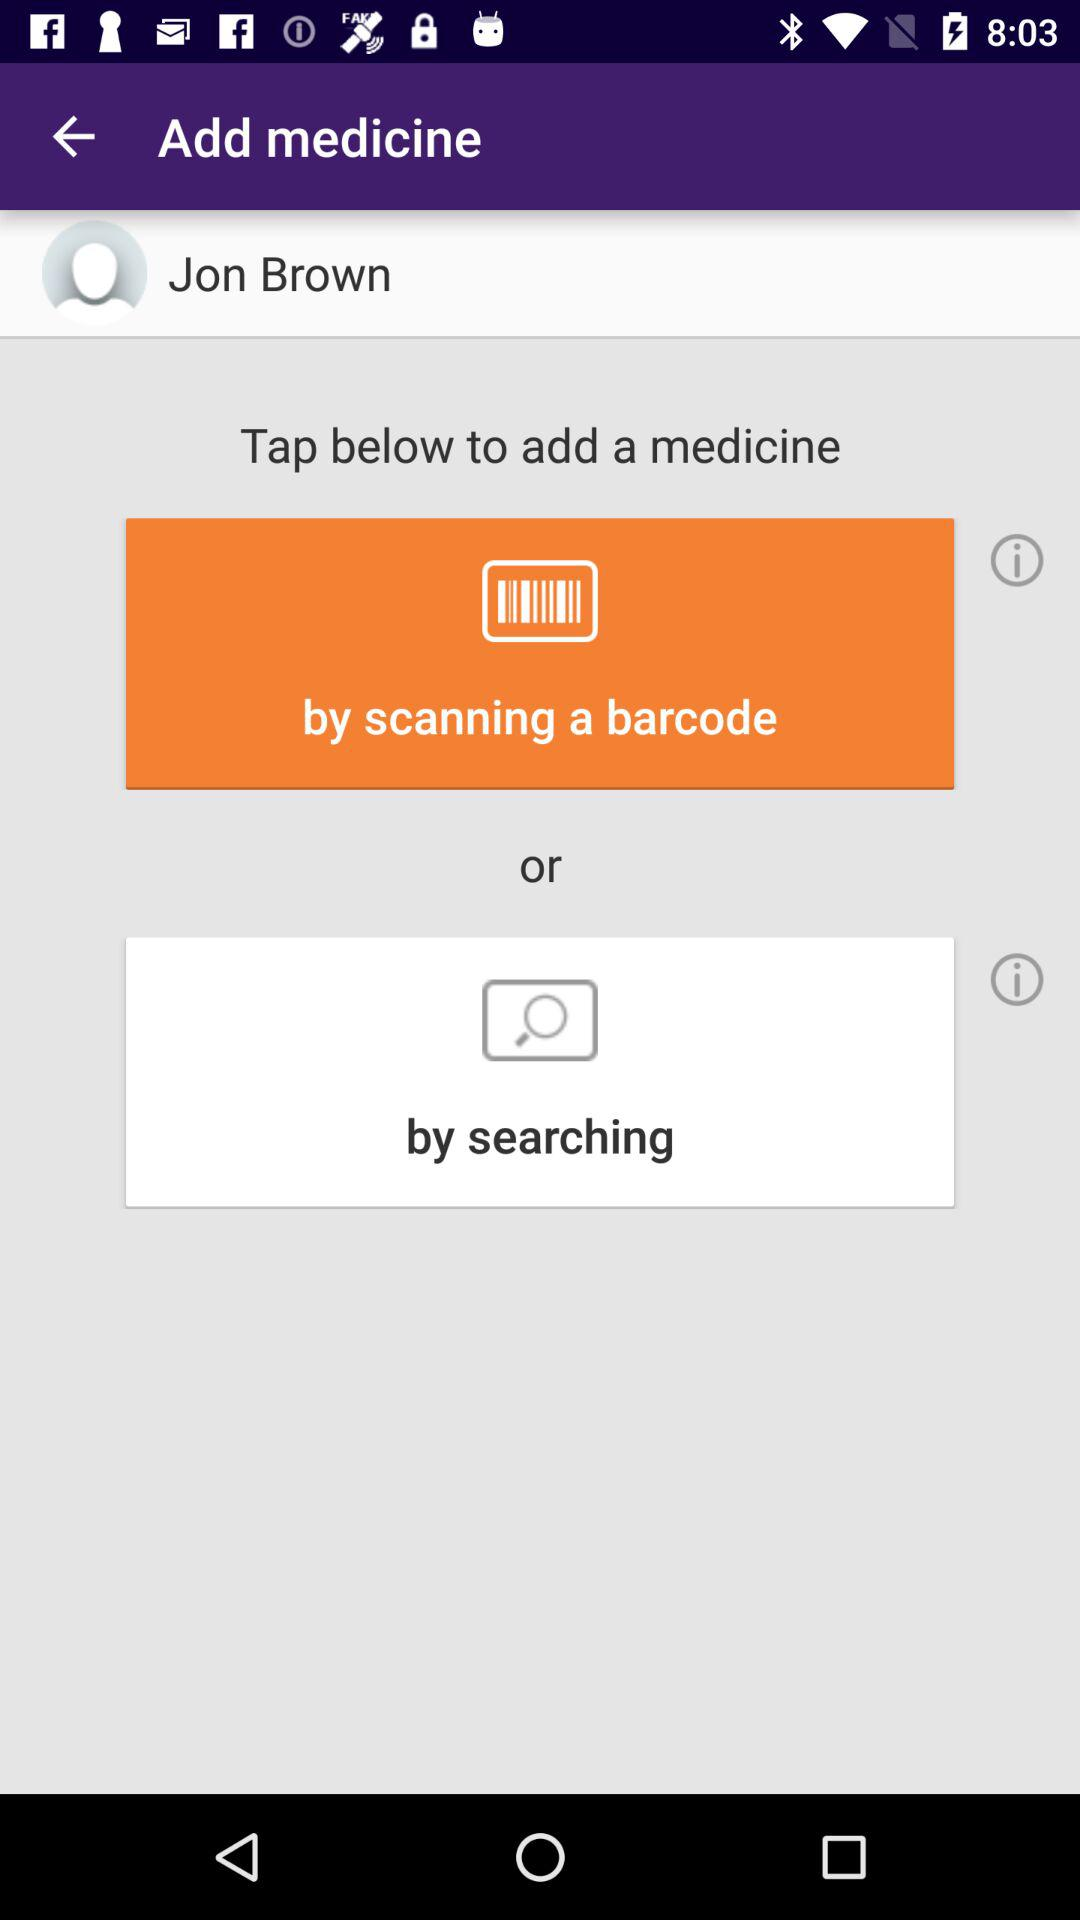What is the name of the user? The name of the user is Jon Brown. 